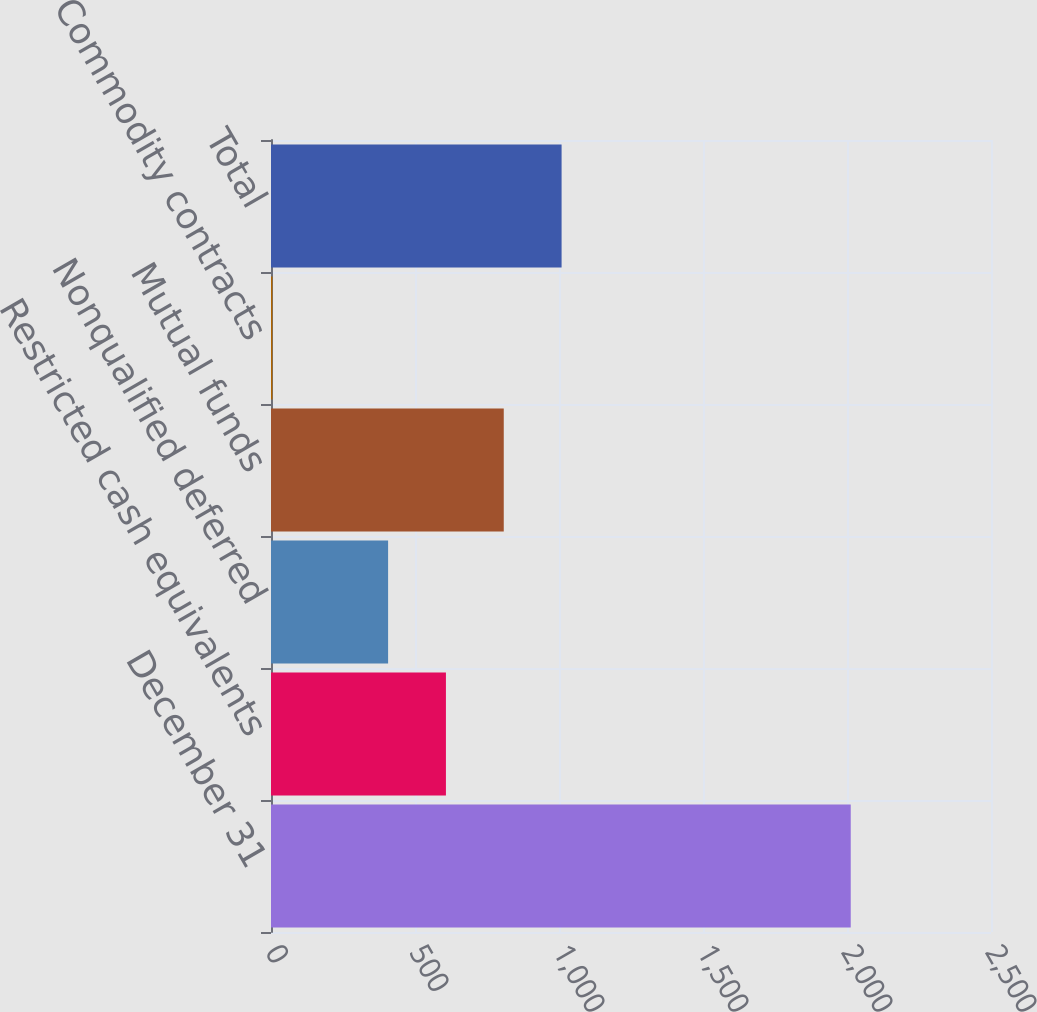<chart> <loc_0><loc_0><loc_500><loc_500><bar_chart><fcel>December 31<fcel>Restricted cash equivalents<fcel>Nonqualified deferred<fcel>Mutual funds<fcel>Commodity contracts<fcel>Total<nl><fcel>2013<fcel>607.4<fcel>406.6<fcel>808.2<fcel>5<fcel>1009<nl></chart> 